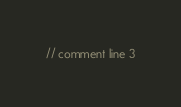<code> <loc_0><loc_0><loc_500><loc_500><_Rust_>// comment line 3
</code> 